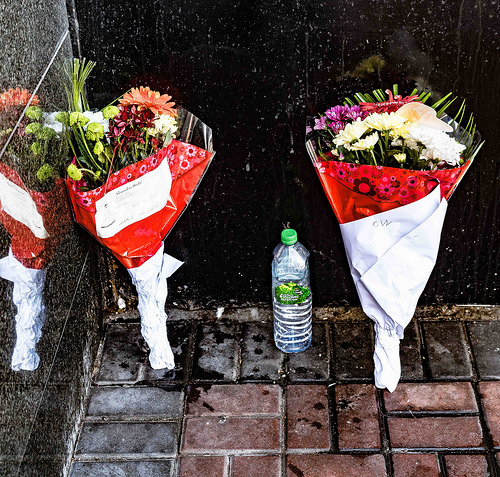<image>
Is there a bottle on the floor? Yes. Looking at the image, I can see the bottle is positioned on top of the floor, with the floor providing support. 